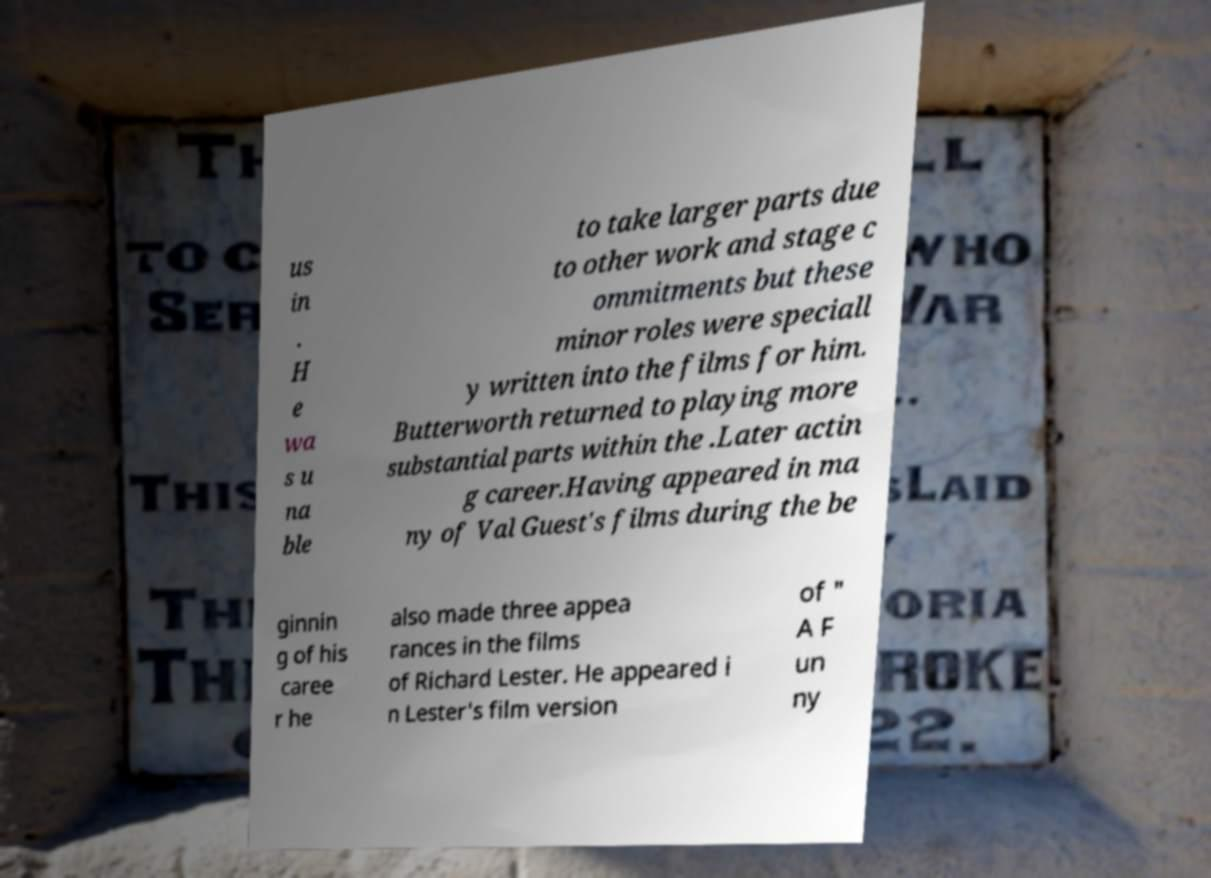There's text embedded in this image that I need extracted. Can you transcribe it verbatim? us in . H e wa s u na ble to take larger parts due to other work and stage c ommitments but these minor roles were speciall y written into the films for him. Butterworth returned to playing more substantial parts within the .Later actin g career.Having appeared in ma ny of Val Guest's films during the be ginnin g of his caree r he also made three appea rances in the films of Richard Lester. He appeared i n Lester's film version of " A F un ny 